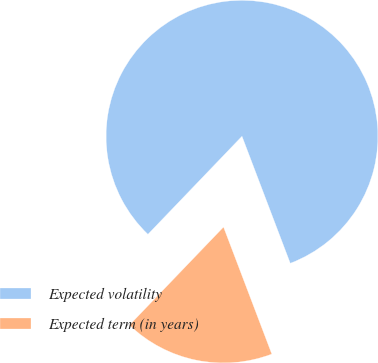Convert chart to OTSL. <chart><loc_0><loc_0><loc_500><loc_500><pie_chart><fcel>Expected volatility<fcel>Expected term (in years)<nl><fcel>82.05%<fcel>17.95%<nl></chart> 